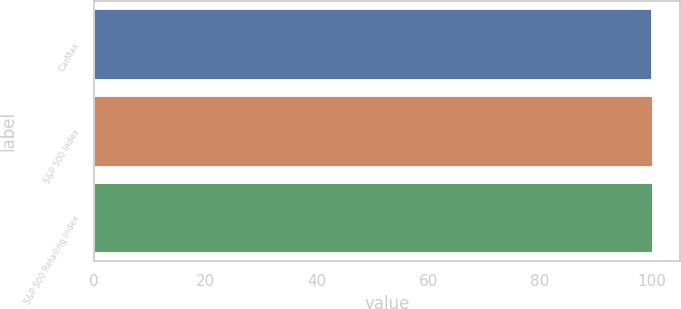<chart> <loc_0><loc_0><loc_500><loc_500><bar_chart><fcel>CarMax<fcel>S&P 500 Index<fcel>S&P 500 Retailing Index<nl><fcel>100<fcel>100.1<fcel>100.2<nl></chart> 